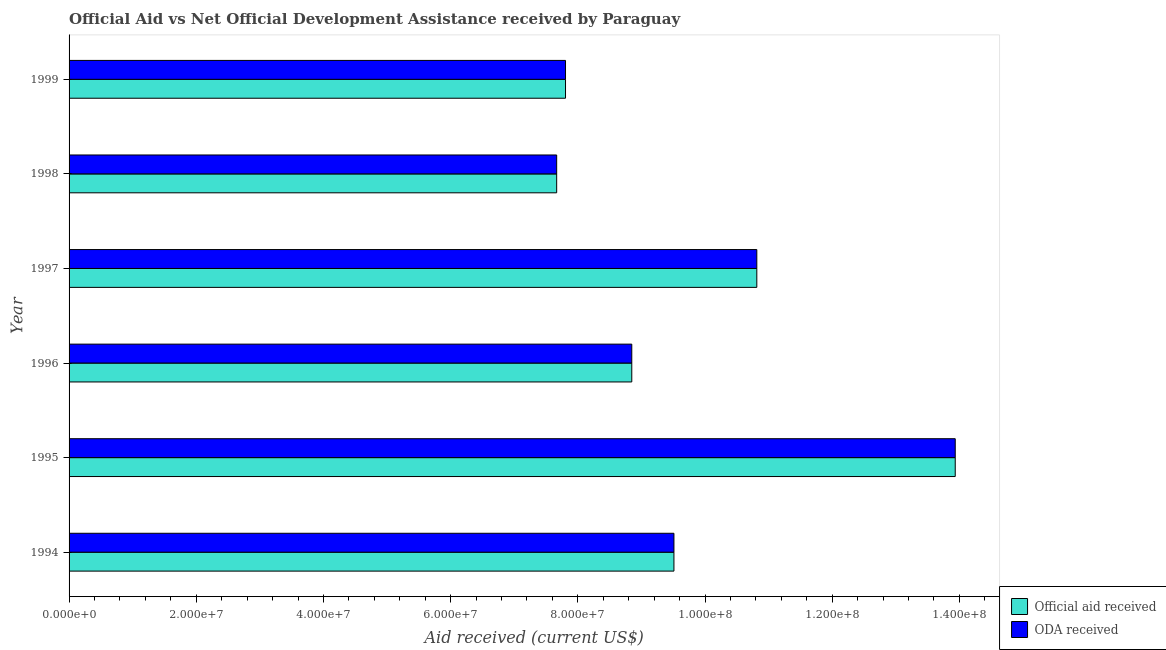Are the number of bars on each tick of the Y-axis equal?
Provide a short and direct response. Yes. How many bars are there on the 6th tick from the bottom?
Keep it short and to the point. 2. What is the oda received in 1997?
Give a very brief answer. 1.08e+08. Across all years, what is the maximum oda received?
Give a very brief answer. 1.39e+08. Across all years, what is the minimum official aid received?
Your response must be concise. 7.67e+07. In which year was the oda received minimum?
Your answer should be compact. 1998. What is the total official aid received in the graph?
Provide a succinct answer. 5.86e+08. What is the difference between the oda received in 1995 and that in 1998?
Your answer should be very brief. 6.27e+07. What is the difference between the official aid received in 1998 and the oda received in 1994?
Offer a terse response. -1.84e+07. What is the average official aid received per year?
Make the answer very short. 9.76e+07. In how many years, is the oda received greater than 12000000 US$?
Your answer should be very brief. 6. What is the ratio of the oda received in 1996 to that in 1998?
Give a very brief answer. 1.15. Is the oda received in 1996 less than that in 1997?
Ensure brevity in your answer.  Yes. What is the difference between the highest and the second highest official aid received?
Make the answer very short. 3.12e+07. What is the difference between the highest and the lowest oda received?
Offer a terse response. 6.27e+07. What does the 2nd bar from the top in 1995 represents?
Your answer should be very brief. Official aid received. What does the 1st bar from the bottom in 1994 represents?
Provide a short and direct response. Official aid received. How many bars are there?
Your response must be concise. 12. Does the graph contain any zero values?
Provide a succinct answer. No. Does the graph contain grids?
Make the answer very short. No. Where does the legend appear in the graph?
Provide a succinct answer. Bottom right. How are the legend labels stacked?
Offer a very short reply. Vertical. What is the title of the graph?
Offer a terse response. Official Aid vs Net Official Development Assistance received by Paraguay . What is the label or title of the X-axis?
Your answer should be compact. Aid received (current US$). What is the label or title of the Y-axis?
Give a very brief answer. Year. What is the Aid received (current US$) in Official aid received in 1994?
Your answer should be very brief. 9.51e+07. What is the Aid received (current US$) in ODA received in 1994?
Provide a succinct answer. 9.51e+07. What is the Aid received (current US$) in Official aid received in 1995?
Your response must be concise. 1.39e+08. What is the Aid received (current US$) in ODA received in 1995?
Your answer should be very brief. 1.39e+08. What is the Aid received (current US$) of Official aid received in 1996?
Ensure brevity in your answer.  8.85e+07. What is the Aid received (current US$) of ODA received in 1996?
Ensure brevity in your answer.  8.85e+07. What is the Aid received (current US$) in Official aid received in 1997?
Provide a succinct answer. 1.08e+08. What is the Aid received (current US$) of ODA received in 1997?
Your response must be concise. 1.08e+08. What is the Aid received (current US$) in Official aid received in 1998?
Offer a very short reply. 7.67e+07. What is the Aid received (current US$) of ODA received in 1998?
Give a very brief answer. 7.67e+07. What is the Aid received (current US$) in Official aid received in 1999?
Offer a terse response. 7.81e+07. What is the Aid received (current US$) of ODA received in 1999?
Offer a terse response. 7.81e+07. Across all years, what is the maximum Aid received (current US$) of Official aid received?
Give a very brief answer. 1.39e+08. Across all years, what is the maximum Aid received (current US$) of ODA received?
Provide a short and direct response. 1.39e+08. Across all years, what is the minimum Aid received (current US$) in Official aid received?
Give a very brief answer. 7.67e+07. Across all years, what is the minimum Aid received (current US$) of ODA received?
Your answer should be compact. 7.67e+07. What is the total Aid received (current US$) in Official aid received in the graph?
Offer a very short reply. 5.86e+08. What is the total Aid received (current US$) of ODA received in the graph?
Provide a succinct answer. 5.86e+08. What is the difference between the Aid received (current US$) in Official aid received in 1994 and that in 1995?
Give a very brief answer. -4.42e+07. What is the difference between the Aid received (current US$) of ODA received in 1994 and that in 1995?
Offer a terse response. -4.42e+07. What is the difference between the Aid received (current US$) of Official aid received in 1994 and that in 1996?
Keep it short and to the point. 6.63e+06. What is the difference between the Aid received (current US$) in ODA received in 1994 and that in 1996?
Your answer should be compact. 6.63e+06. What is the difference between the Aid received (current US$) of Official aid received in 1994 and that in 1997?
Provide a succinct answer. -1.30e+07. What is the difference between the Aid received (current US$) of ODA received in 1994 and that in 1997?
Your response must be concise. -1.30e+07. What is the difference between the Aid received (current US$) of Official aid received in 1994 and that in 1998?
Offer a very short reply. 1.84e+07. What is the difference between the Aid received (current US$) in ODA received in 1994 and that in 1998?
Keep it short and to the point. 1.84e+07. What is the difference between the Aid received (current US$) in Official aid received in 1994 and that in 1999?
Your answer should be compact. 1.70e+07. What is the difference between the Aid received (current US$) in ODA received in 1994 and that in 1999?
Make the answer very short. 1.70e+07. What is the difference between the Aid received (current US$) in Official aid received in 1995 and that in 1996?
Provide a succinct answer. 5.09e+07. What is the difference between the Aid received (current US$) of ODA received in 1995 and that in 1996?
Offer a very short reply. 5.09e+07. What is the difference between the Aid received (current US$) in Official aid received in 1995 and that in 1997?
Provide a succinct answer. 3.12e+07. What is the difference between the Aid received (current US$) in ODA received in 1995 and that in 1997?
Provide a short and direct response. 3.12e+07. What is the difference between the Aid received (current US$) of Official aid received in 1995 and that in 1998?
Your answer should be very brief. 6.27e+07. What is the difference between the Aid received (current US$) of ODA received in 1995 and that in 1998?
Provide a short and direct response. 6.27e+07. What is the difference between the Aid received (current US$) of Official aid received in 1995 and that in 1999?
Provide a succinct answer. 6.13e+07. What is the difference between the Aid received (current US$) in ODA received in 1995 and that in 1999?
Your answer should be compact. 6.13e+07. What is the difference between the Aid received (current US$) of Official aid received in 1996 and that in 1997?
Your answer should be very brief. -1.97e+07. What is the difference between the Aid received (current US$) in ODA received in 1996 and that in 1997?
Provide a succinct answer. -1.97e+07. What is the difference between the Aid received (current US$) of Official aid received in 1996 and that in 1998?
Provide a succinct answer. 1.18e+07. What is the difference between the Aid received (current US$) of ODA received in 1996 and that in 1998?
Your answer should be very brief. 1.18e+07. What is the difference between the Aid received (current US$) of Official aid received in 1996 and that in 1999?
Give a very brief answer. 1.04e+07. What is the difference between the Aid received (current US$) of ODA received in 1996 and that in 1999?
Offer a very short reply. 1.04e+07. What is the difference between the Aid received (current US$) in Official aid received in 1997 and that in 1998?
Make the answer very short. 3.15e+07. What is the difference between the Aid received (current US$) in ODA received in 1997 and that in 1998?
Keep it short and to the point. 3.15e+07. What is the difference between the Aid received (current US$) of Official aid received in 1997 and that in 1999?
Offer a very short reply. 3.01e+07. What is the difference between the Aid received (current US$) in ODA received in 1997 and that in 1999?
Keep it short and to the point. 3.01e+07. What is the difference between the Aid received (current US$) of Official aid received in 1998 and that in 1999?
Offer a terse response. -1.39e+06. What is the difference between the Aid received (current US$) of ODA received in 1998 and that in 1999?
Ensure brevity in your answer.  -1.39e+06. What is the difference between the Aid received (current US$) in Official aid received in 1994 and the Aid received (current US$) in ODA received in 1995?
Provide a succinct answer. -4.42e+07. What is the difference between the Aid received (current US$) of Official aid received in 1994 and the Aid received (current US$) of ODA received in 1996?
Ensure brevity in your answer.  6.63e+06. What is the difference between the Aid received (current US$) in Official aid received in 1994 and the Aid received (current US$) in ODA received in 1997?
Offer a terse response. -1.30e+07. What is the difference between the Aid received (current US$) in Official aid received in 1994 and the Aid received (current US$) in ODA received in 1998?
Your answer should be very brief. 1.84e+07. What is the difference between the Aid received (current US$) of Official aid received in 1994 and the Aid received (current US$) of ODA received in 1999?
Keep it short and to the point. 1.70e+07. What is the difference between the Aid received (current US$) of Official aid received in 1995 and the Aid received (current US$) of ODA received in 1996?
Your answer should be compact. 5.09e+07. What is the difference between the Aid received (current US$) in Official aid received in 1995 and the Aid received (current US$) in ODA received in 1997?
Keep it short and to the point. 3.12e+07. What is the difference between the Aid received (current US$) in Official aid received in 1995 and the Aid received (current US$) in ODA received in 1998?
Offer a terse response. 6.27e+07. What is the difference between the Aid received (current US$) in Official aid received in 1995 and the Aid received (current US$) in ODA received in 1999?
Provide a succinct answer. 6.13e+07. What is the difference between the Aid received (current US$) in Official aid received in 1996 and the Aid received (current US$) in ODA received in 1997?
Your answer should be compact. -1.97e+07. What is the difference between the Aid received (current US$) in Official aid received in 1996 and the Aid received (current US$) in ODA received in 1998?
Offer a terse response. 1.18e+07. What is the difference between the Aid received (current US$) in Official aid received in 1996 and the Aid received (current US$) in ODA received in 1999?
Your answer should be compact. 1.04e+07. What is the difference between the Aid received (current US$) of Official aid received in 1997 and the Aid received (current US$) of ODA received in 1998?
Offer a terse response. 3.15e+07. What is the difference between the Aid received (current US$) in Official aid received in 1997 and the Aid received (current US$) in ODA received in 1999?
Provide a short and direct response. 3.01e+07. What is the difference between the Aid received (current US$) of Official aid received in 1998 and the Aid received (current US$) of ODA received in 1999?
Ensure brevity in your answer.  -1.39e+06. What is the average Aid received (current US$) of Official aid received per year?
Your response must be concise. 9.76e+07. What is the average Aid received (current US$) of ODA received per year?
Provide a short and direct response. 9.76e+07. In the year 1995, what is the difference between the Aid received (current US$) in Official aid received and Aid received (current US$) in ODA received?
Provide a short and direct response. 0. In the year 1998, what is the difference between the Aid received (current US$) of Official aid received and Aid received (current US$) of ODA received?
Ensure brevity in your answer.  0. What is the ratio of the Aid received (current US$) in Official aid received in 1994 to that in 1995?
Give a very brief answer. 0.68. What is the ratio of the Aid received (current US$) in ODA received in 1994 to that in 1995?
Your response must be concise. 0.68. What is the ratio of the Aid received (current US$) in Official aid received in 1994 to that in 1996?
Offer a terse response. 1.07. What is the ratio of the Aid received (current US$) in ODA received in 1994 to that in 1996?
Offer a very short reply. 1.07. What is the ratio of the Aid received (current US$) in Official aid received in 1994 to that in 1997?
Provide a short and direct response. 0.88. What is the ratio of the Aid received (current US$) in ODA received in 1994 to that in 1997?
Give a very brief answer. 0.88. What is the ratio of the Aid received (current US$) in Official aid received in 1994 to that in 1998?
Give a very brief answer. 1.24. What is the ratio of the Aid received (current US$) of ODA received in 1994 to that in 1998?
Make the answer very short. 1.24. What is the ratio of the Aid received (current US$) in Official aid received in 1994 to that in 1999?
Make the answer very short. 1.22. What is the ratio of the Aid received (current US$) in ODA received in 1994 to that in 1999?
Your response must be concise. 1.22. What is the ratio of the Aid received (current US$) of Official aid received in 1995 to that in 1996?
Ensure brevity in your answer.  1.57. What is the ratio of the Aid received (current US$) in ODA received in 1995 to that in 1996?
Provide a succinct answer. 1.57. What is the ratio of the Aid received (current US$) in Official aid received in 1995 to that in 1997?
Make the answer very short. 1.29. What is the ratio of the Aid received (current US$) in ODA received in 1995 to that in 1997?
Your answer should be very brief. 1.29. What is the ratio of the Aid received (current US$) of Official aid received in 1995 to that in 1998?
Offer a terse response. 1.82. What is the ratio of the Aid received (current US$) in ODA received in 1995 to that in 1998?
Provide a succinct answer. 1.82. What is the ratio of the Aid received (current US$) in Official aid received in 1995 to that in 1999?
Keep it short and to the point. 1.78. What is the ratio of the Aid received (current US$) of ODA received in 1995 to that in 1999?
Ensure brevity in your answer.  1.78. What is the ratio of the Aid received (current US$) of Official aid received in 1996 to that in 1997?
Your response must be concise. 0.82. What is the ratio of the Aid received (current US$) in ODA received in 1996 to that in 1997?
Your answer should be compact. 0.82. What is the ratio of the Aid received (current US$) in Official aid received in 1996 to that in 1998?
Offer a very short reply. 1.15. What is the ratio of the Aid received (current US$) of ODA received in 1996 to that in 1998?
Give a very brief answer. 1.15. What is the ratio of the Aid received (current US$) of Official aid received in 1996 to that in 1999?
Provide a short and direct response. 1.13. What is the ratio of the Aid received (current US$) of ODA received in 1996 to that in 1999?
Make the answer very short. 1.13. What is the ratio of the Aid received (current US$) in Official aid received in 1997 to that in 1998?
Your response must be concise. 1.41. What is the ratio of the Aid received (current US$) in ODA received in 1997 to that in 1998?
Provide a short and direct response. 1.41. What is the ratio of the Aid received (current US$) of Official aid received in 1997 to that in 1999?
Keep it short and to the point. 1.39. What is the ratio of the Aid received (current US$) of ODA received in 1997 to that in 1999?
Your answer should be compact. 1.39. What is the ratio of the Aid received (current US$) of Official aid received in 1998 to that in 1999?
Your answer should be compact. 0.98. What is the ratio of the Aid received (current US$) in ODA received in 1998 to that in 1999?
Give a very brief answer. 0.98. What is the difference between the highest and the second highest Aid received (current US$) in Official aid received?
Make the answer very short. 3.12e+07. What is the difference between the highest and the second highest Aid received (current US$) in ODA received?
Provide a succinct answer. 3.12e+07. What is the difference between the highest and the lowest Aid received (current US$) of Official aid received?
Your answer should be very brief. 6.27e+07. What is the difference between the highest and the lowest Aid received (current US$) in ODA received?
Your response must be concise. 6.27e+07. 